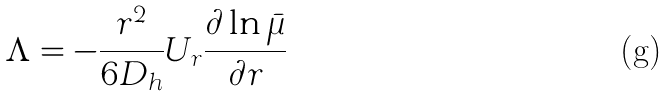Convert formula to latex. <formula><loc_0><loc_0><loc_500><loc_500>\Lambda = - \frac { r ^ { 2 } } { 6 D _ { h } } U _ { r } \frac { \partial \ln \bar { \mu } } { \partial r }</formula> 